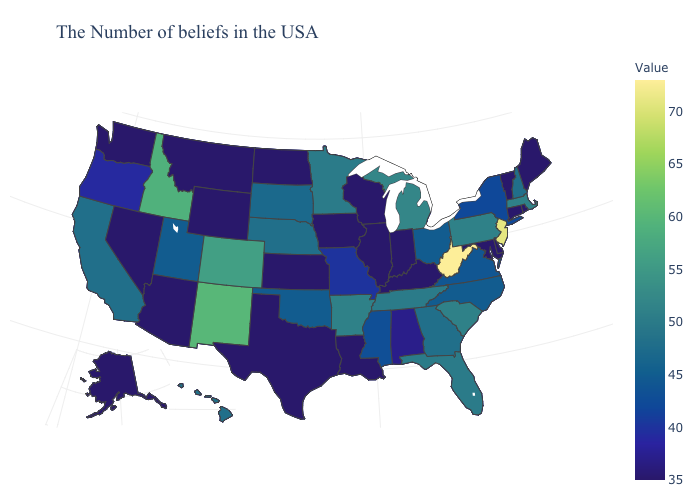Is the legend a continuous bar?
Concise answer only. Yes. Does Vermont have a higher value than South Carolina?
Be succinct. No. Which states have the lowest value in the South?
Concise answer only. Delaware, Maryland, Kentucky, Louisiana, Texas. Does the map have missing data?
Short answer required. No. Which states hav the highest value in the South?
Quick response, please. West Virginia. 